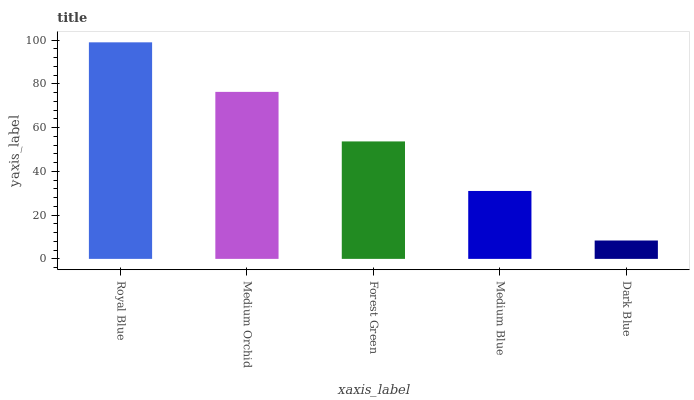Is Dark Blue the minimum?
Answer yes or no. Yes. Is Royal Blue the maximum?
Answer yes or no. Yes. Is Medium Orchid the minimum?
Answer yes or no. No. Is Medium Orchid the maximum?
Answer yes or no. No. Is Royal Blue greater than Medium Orchid?
Answer yes or no. Yes. Is Medium Orchid less than Royal Blue?
Answer yes or no. Yes. Is Medium Orchid greater than Royal Blue?
Answer yes or no. No. Is Royal Blue less than Medium Orchid?
Answer yes or no. No. Is Forest Green the high median?
Answer yes or no. Yes. Is Forest Green the low median?
Answer yes or no. Yes. Is Royal Blue the high median?
Answer yes or no. No. Is Medium Orchid the low median?
Answer yes or no. No. 